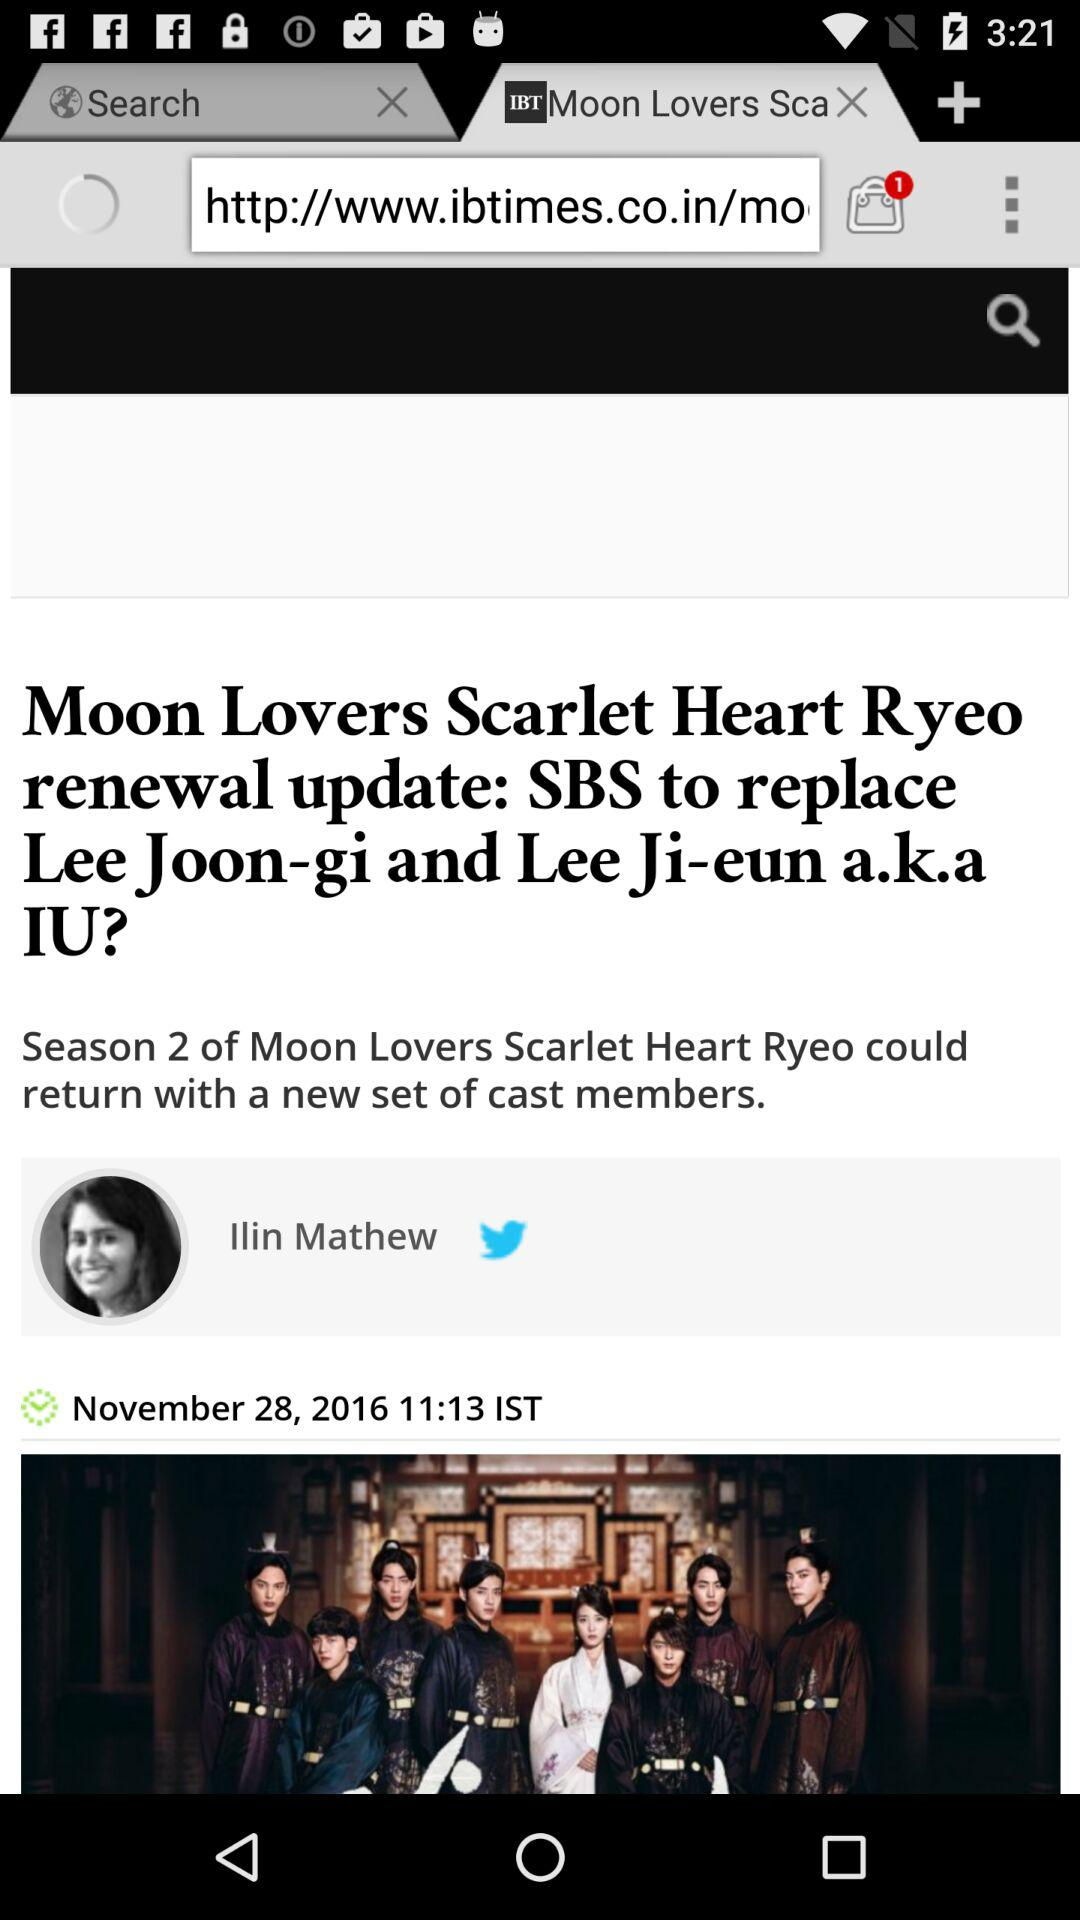What is the time of publication? The time of publication is 11:13 IST. 